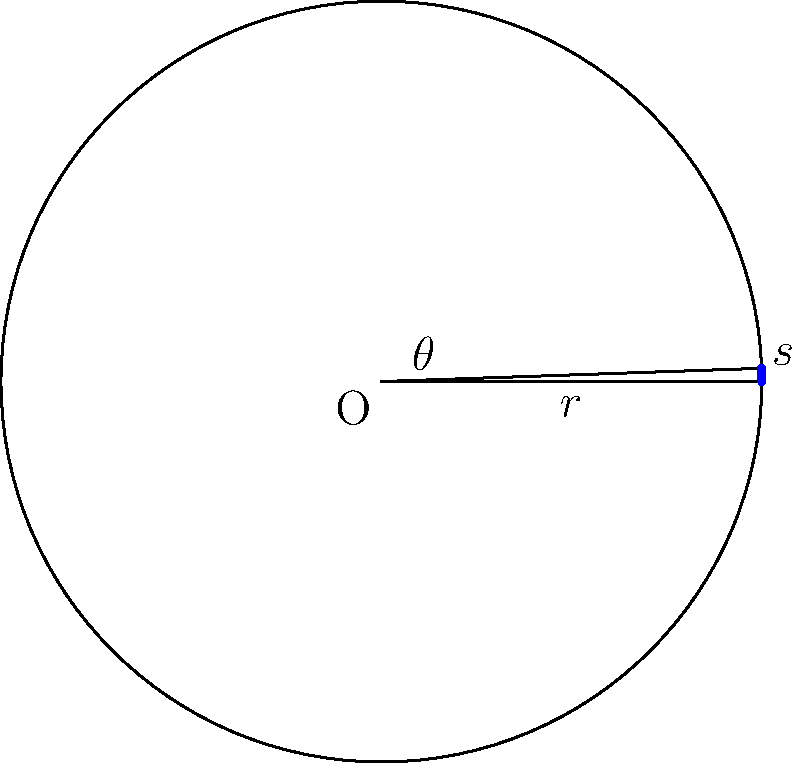As a graphic designer working on a circular progress bar for a website, you need to calculate the central angle for a given arc length. If the radius of the progress bar is 150 pixels and the arc length is 235.62 pixels, what is the central angle in radians? To find the central angle of a circular arc, we can use the formula:

$$s = r\theta$$

Where:
$s$ = arc length
$r$ = radius
$\theta$ = central angle in radians

Given:
$r = 150$ pixels
$s = 235.62$ pixels

Step 1: Rearrange the formula to solve for $\theta$:
$$\theta = \frac{s}{r}$$

Step 2: Substitute the known values:
$$\theta = \frac{235.62}{150}$$

Step 3: Calculate the result:
$$\theta = 1.5708 \text{ radians}$$

This central angle can be used in your website's CSS or JavaScript to set the appropriate arc length for the circular progress bar.
Answer: $1.5708 \text{ radians}$ 